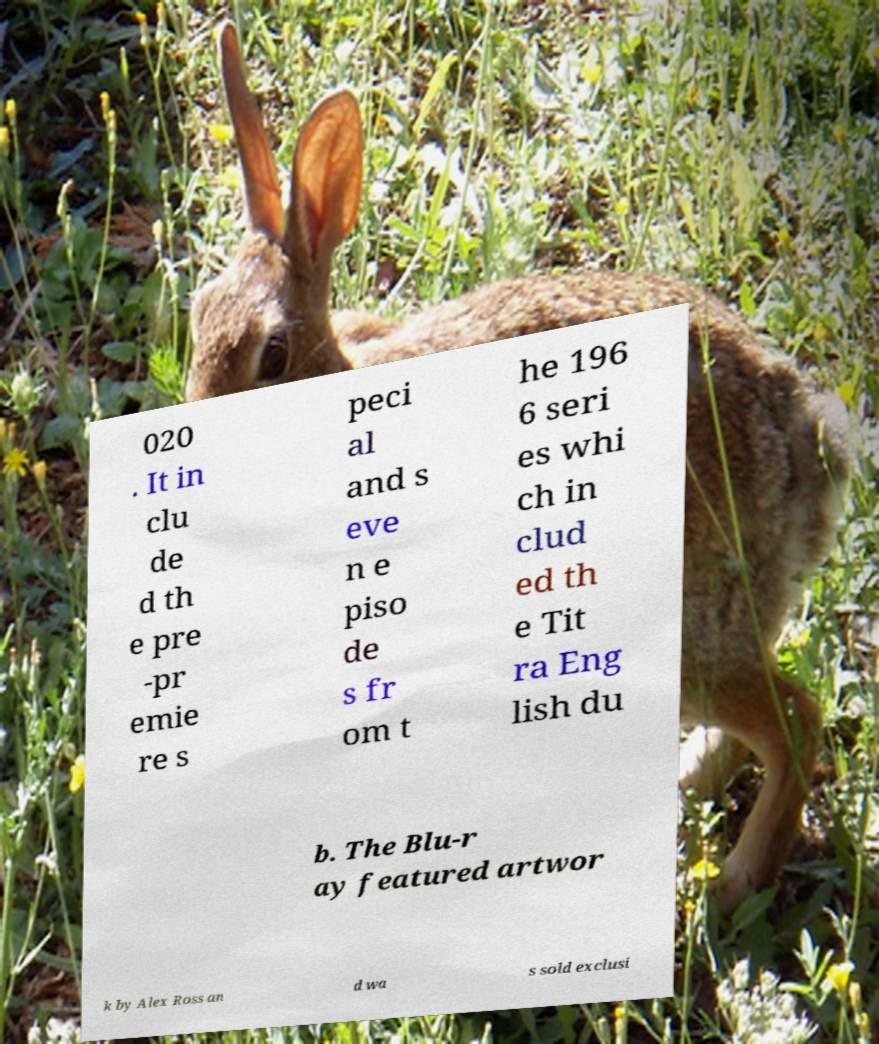Could you extract and type out the text from this image? 020 . It in clu de d th e pre -pr emie re s peci al and s eve n e piso de s fr om t he 196 6 seri es whi ch in clud ed th e Tit ra Eng lish du b. The Blu-r ay featured artwor k by Alex Ross an d wa s sold exclusi 